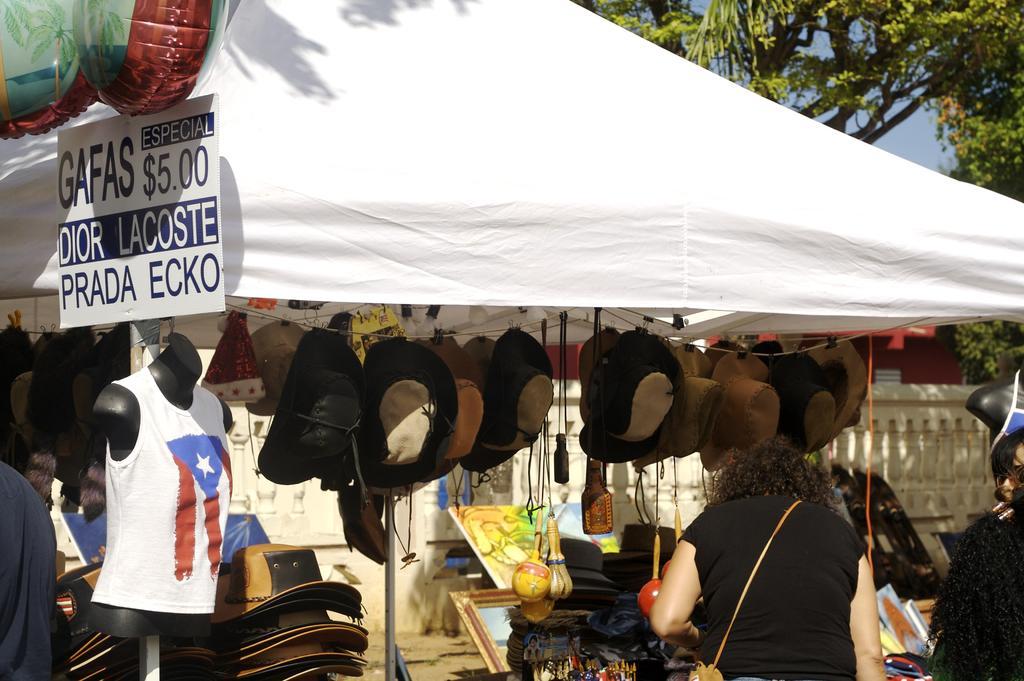Could you give a brief overview of what you see in this image? In this image there is a person and a mannequin on the left corner. There are people, trees on the right corner. It looks like a stall there are hats, toys. There is a sky. We can see the white colored cloth. 